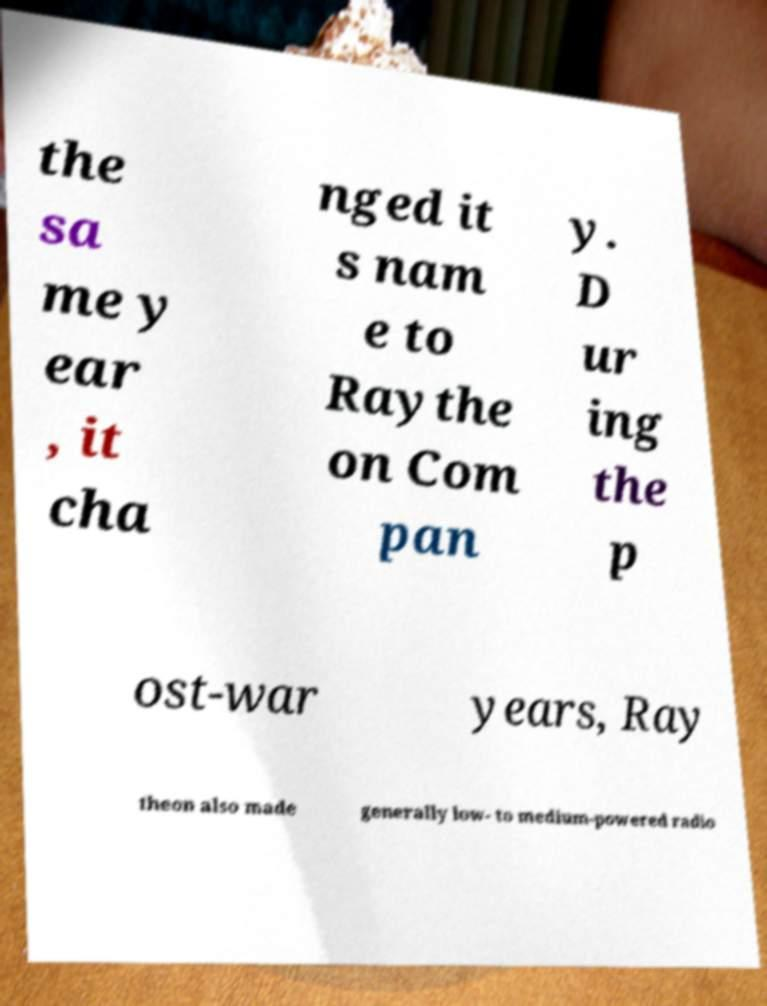Could you extract and type out the text from this image? the sa me y ear , it cha nged it s nam e to Raythe on Com pan y. D ur ing the p ost-war years, Ray theon also made generally low- to medium-powered radio 